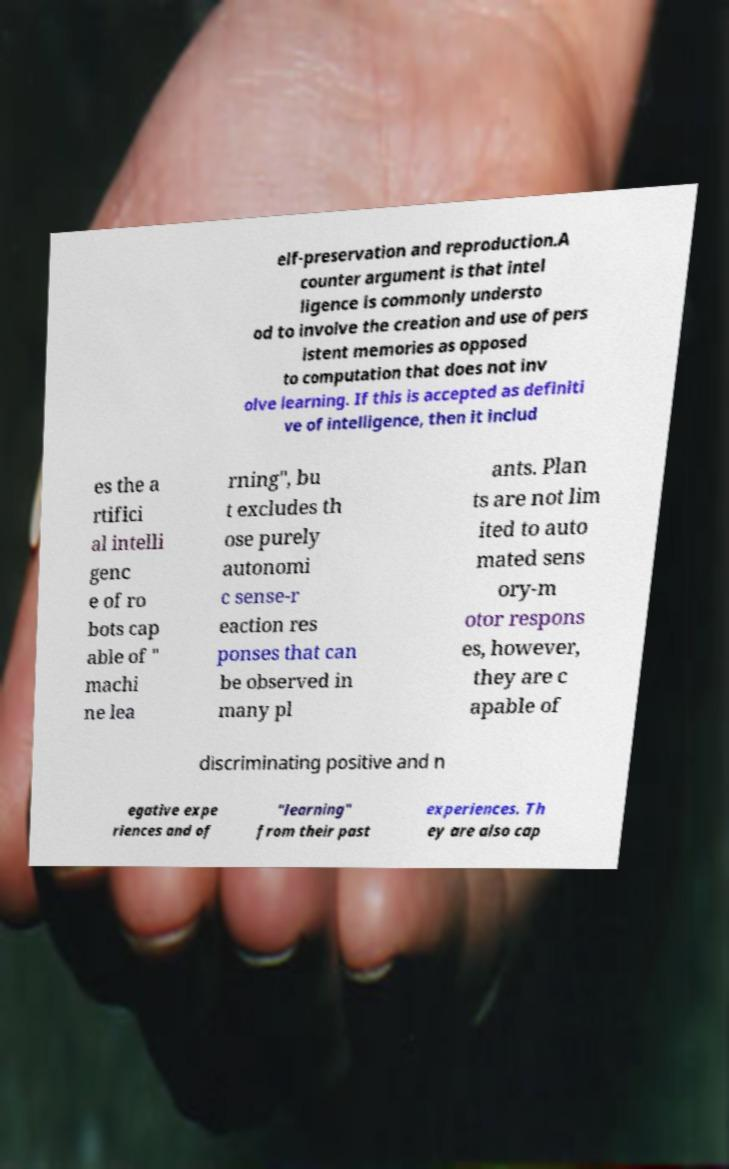Could you assist in decoding the text presented in this image and type it out clearly? elf-preservation and reproduction.A counter argument is that intel ligence is commonly understo od to involve the creation and use of pers istent memories as opposed to computation that does not inv olve learning. If this is accepted as definiti ve of intelligence, then it includ es the a rtifici al intelli genc e of ro bots cap able of " machi ne lea rning", bu t excludes th ose purely autonomi c sense-r eaction res ponses that can be observed in many pl ants. Plan ts are not lim ited to auto mated sens ory-m otor respons es, however, they are c apable of discriminating positive and n egative expe riences and of "learning" from their past experiences. Th ey are also cap 